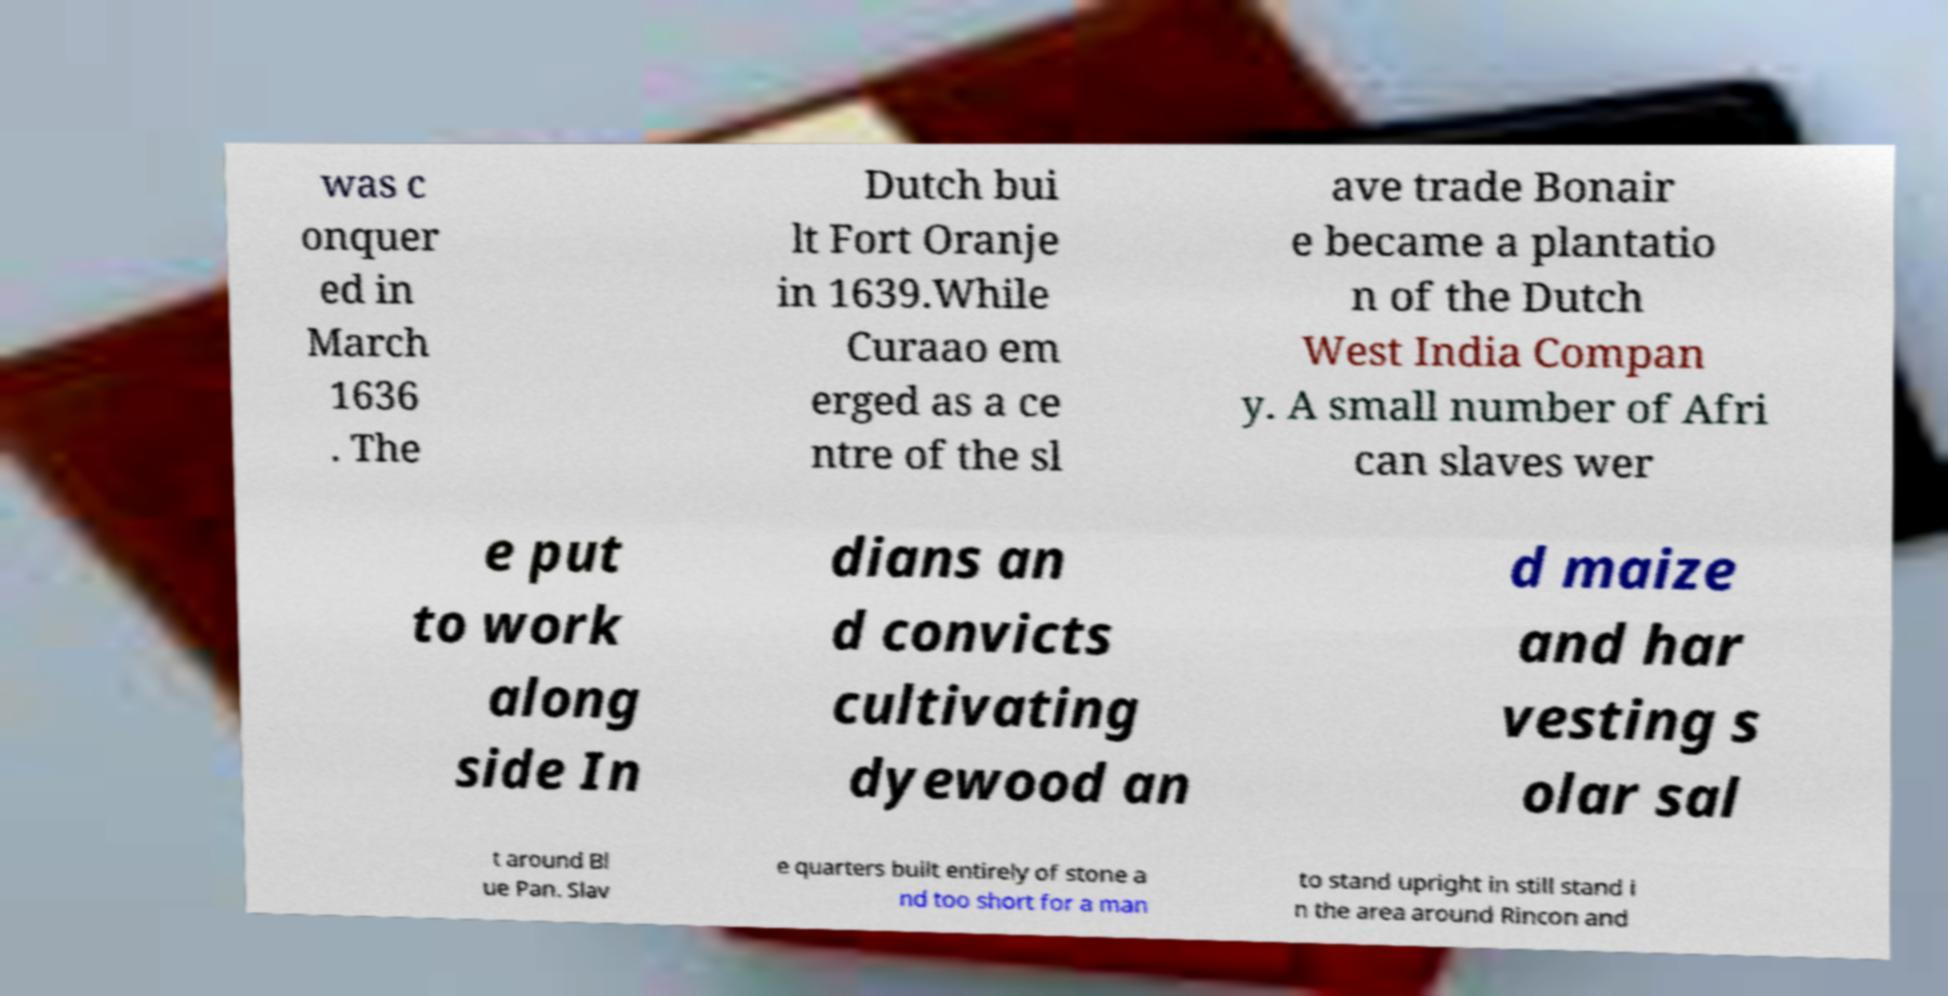Please read and relay the text visible in this image. What does it say? was c onquer ed in March 1636 . The Dutch bui lt Fort Oranje in 1639.While Curaao em erged as a ce ntre of the sl ave trade Bonair e became a plantatio n of the Dutch West India Compan y. A small number of Afri can slaves wer e put to work along side In dians an d convicts cultivating dyewood an d maize and har vesting s olar sal t around Bl ue Pan. Slav e quarters built entirely of stone a nd too short for a man to stand upright in still stand i n the area around Rincon and 